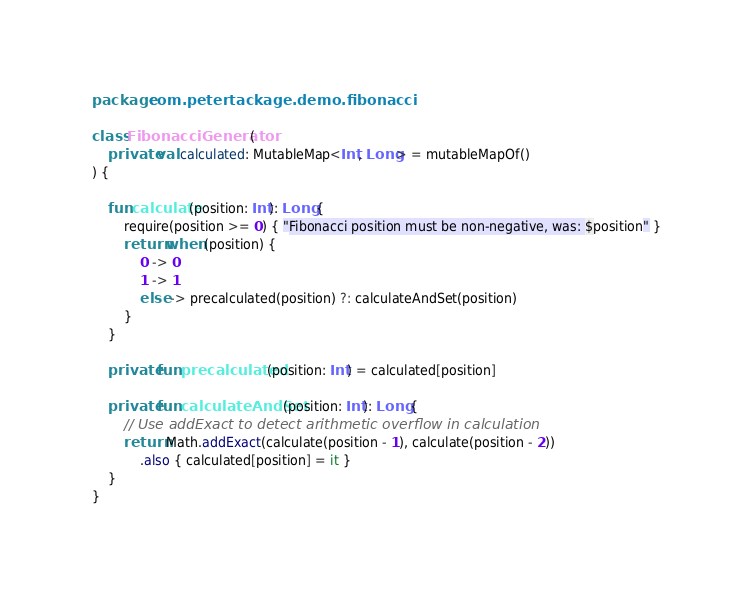Convert code to text. <code><loc_0><loc_0><loc_500><loc_500><_Kotlin_>package com.petertackage.demo.fibonacci

class FibonacciGenerator(
    private val calculated: MutableMap<Int, Long> = mutableMapOf()
) {

    fun calculate(position: Int): Long {
        require(position >= 0) { "Fibonacci position must be non-negative, was: $position" }
        return when (position) {
            0 -> 0
            1 -> 1
            else -> precalculated(position) ?: calculateAndSet(position)
        }
    }

    private fun precalculated(position: Int) = calculated[position]

    private fun calculateAndSet(position: Int): Long {
        // Use addExact to detect arithmetic overflow in calculation
        return Math.addExact(calculate(position - 1), calculate(position - 2))
            .also { calculated[position] = it }
    }
}
</code> 